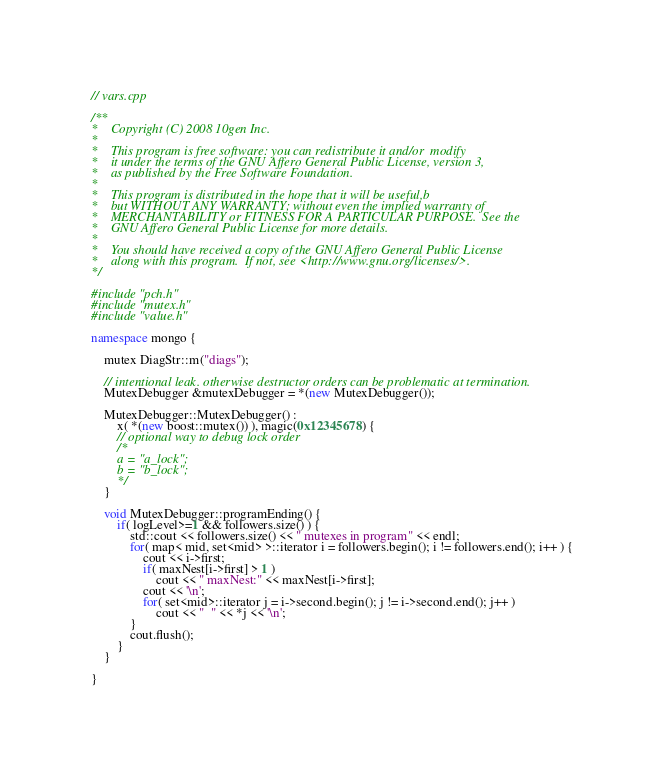Convert code to text. <code><loc_0><loc_0><loc_500><loc_500><_C++_>// vars.cpp

/**
*    Copyright (C) 2008 10gen Inc.
*
*    This program is free software: you can redistribute it and/or  modify
*    it under the terms of the GNU Affero General Public License, version 3,
*    as published by the Free Software Foundation.
*
*    This program is distributed in the hope that it will be useful,b
*    but WITHOUT ANY WARRANTY; without even the implied warranty of
*    MERCHANTABILITY or FITNESS FOR A PARTICULAR PURPOSE.  See the
*    GNU Affero General Public License for more details.
*
*    You should have received a copy of the GNU Affero General Public License
*    along with this program.  If not, see <http://www.gnu.org/licenses/>.
*/

#include "pch.h"
#include "mutex.h"
#include "value.h"

namespace mongo {

    mutex DiagStr::m("diags");

    // intentional leak. otherwise destructor orders can be problematic at termination.
    MutexDebugger &mutexDebugger = *(new MutexDebugger());

    MutexDebugger::MutexDebugger() :
        x( *(new boost::mutex()) ), magic(0x12345678) {
        // optional way to debug lock order
        /*
        a = "a_lock";
        b = "b_lock";
        */
    }

    void MutexDebugger::programEnding() {
        if( logLevel>=1 && followers.size() ) {
            std::cout << followers.size() << " mutexes in program" << endl;
            for( map< mid, set<mid> >::iterator i = followers.begin(); i != followers.end(); i++ ) {
                cout << i->first;
                if( maxNest[i->first] > 1 )
                    cout << " maxNest:" << maxNest[i->first];
                cout << '\n';
                for( set<mid>::iterator j = i->second.begin(); j != i->second.end(); j++ )
                    cout << "  " << *j << '\n';
            }
            cout.flush();
        }
    }

}
</code> 